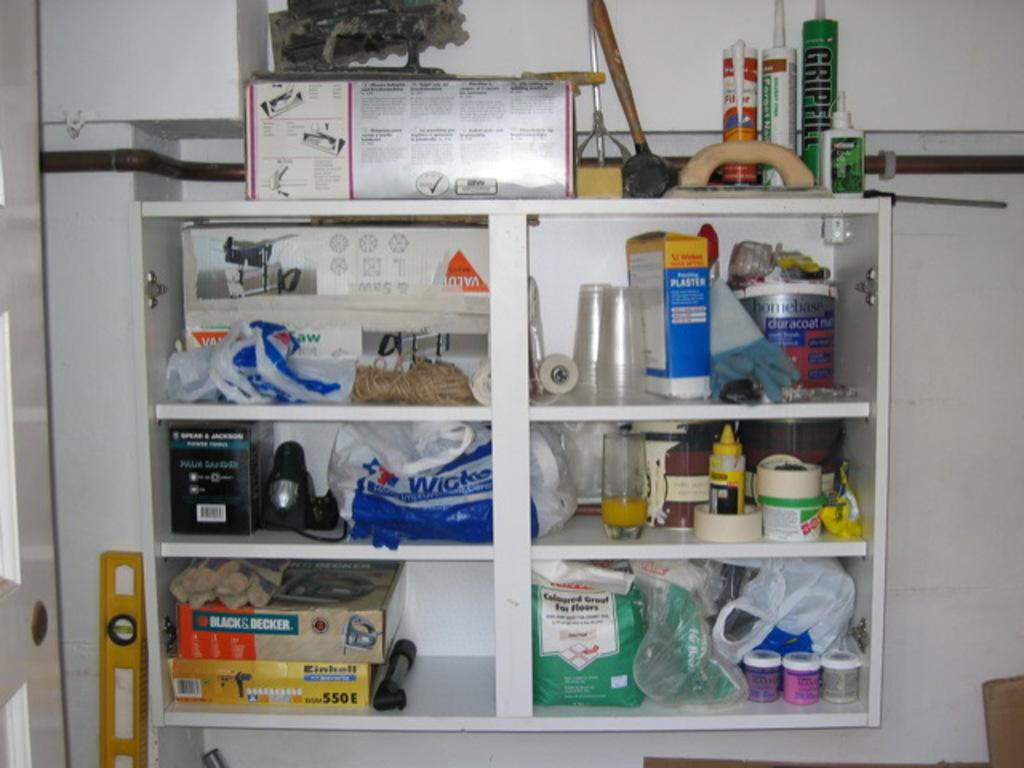<image>
Create a compact narrative representing the image presented. A storage space filled with cups and boxes, with one large box listed as a Black and Decker equipment. 